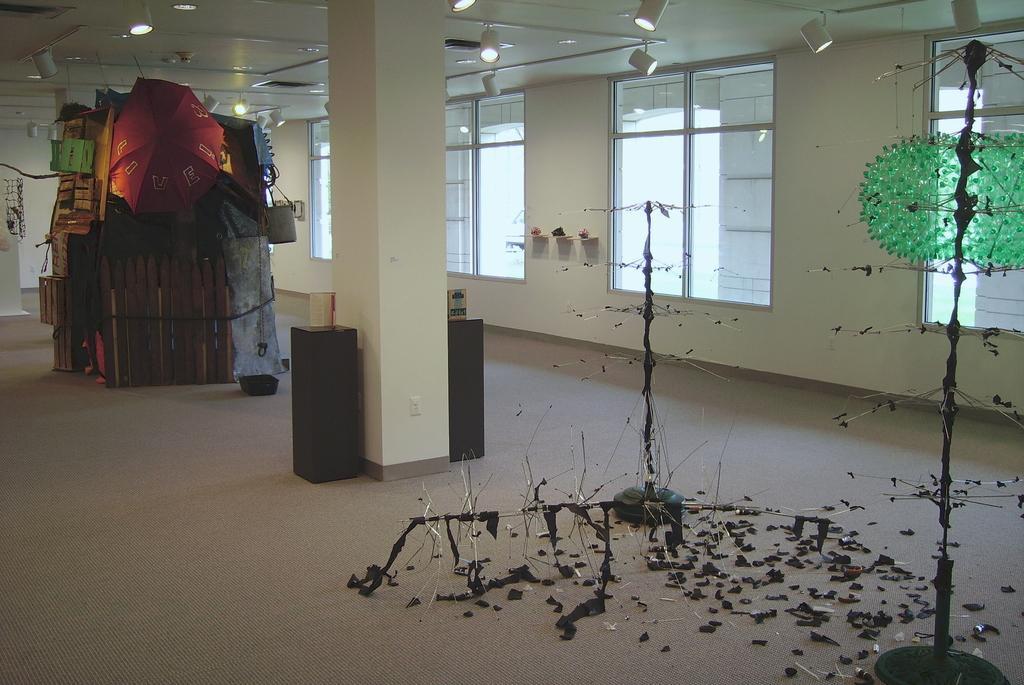Describe this image in one or two sentences. This picture is clicked inside. On the left we can see the wooden planks, umbrella and some other objects and we can see there are some objects placed on the ground and there are some objects lying on the ground. At the top there is a roof and we can see the ceiling lights and focusing lights and we can see the pillars. In the background there is a wall and the windows. 